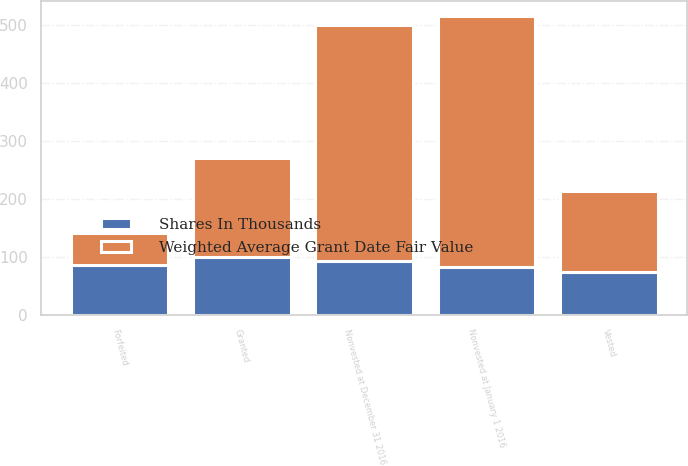<chart> <loc_0><loc_0><loc_500><loc_500><stacked_bar_chart><ecel><fcel>Nonvested at January 1 2016<fcel>Granted<fcel>Vested<fcel>Forfeited<fcel>Nonvested at December 31 2016<nl><fcel>Weighted Average Grant Date Fair Value<fcel>433<fcel>170<fcel>140<fcel>55<fcel>408<nl><fcel>Shares In Thousands<fcel>82<fcel>100<fcel>73<fcel>86<fcel>92<nl></chart> 